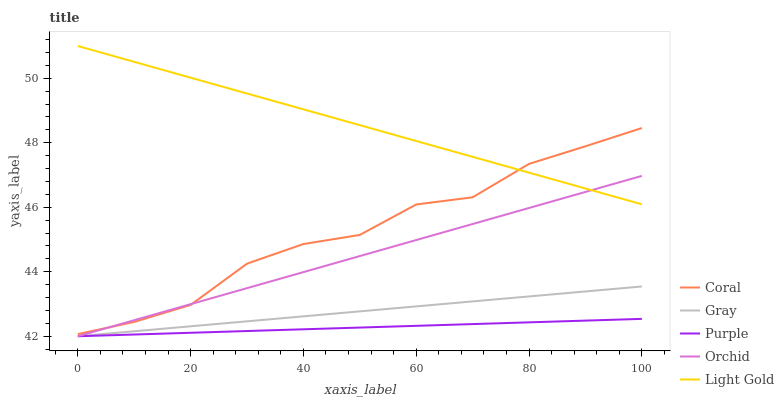Does Purple have the minimum area under the curve?
Answer yes or no. Yes. Does Light Gold have the maximum area under the curve?
Answer yes or no. Yes. Does Gray have the minimum area under the curve?
Answer yes or no. No. Does Gray have the maximum area under the curve?
Answer yes or no. No. Is Orchid the smoothest?
Answer yes or no. Yes. Is Coral the roughest?
Answer yes or no. Yes. Is Gray the smoothest?
Answer yes or no. No. Is Gray the roughest?
Answer yes or no. No. Does Coral have the lowest value?
Answer yes or no. No. Does Light Gold have the highest value?
Answer yes or no. Yes. Does Gray have the highest value?
Answer yes or no. No. Is Gray less than Light Gold?
Answer yes or no. Yes. Is Coral greater than Purple?
Answer yes or no. Yes. Does Coral intersect Light Gold?
Answer yes or no. Yes. Is Coral less than Light Gold?
Answer yes or no. No. Is Coral greater than Light Gold?
Answer yes or no. No. Does Gray intersect Light Gold?
Answer yes or no. No. 